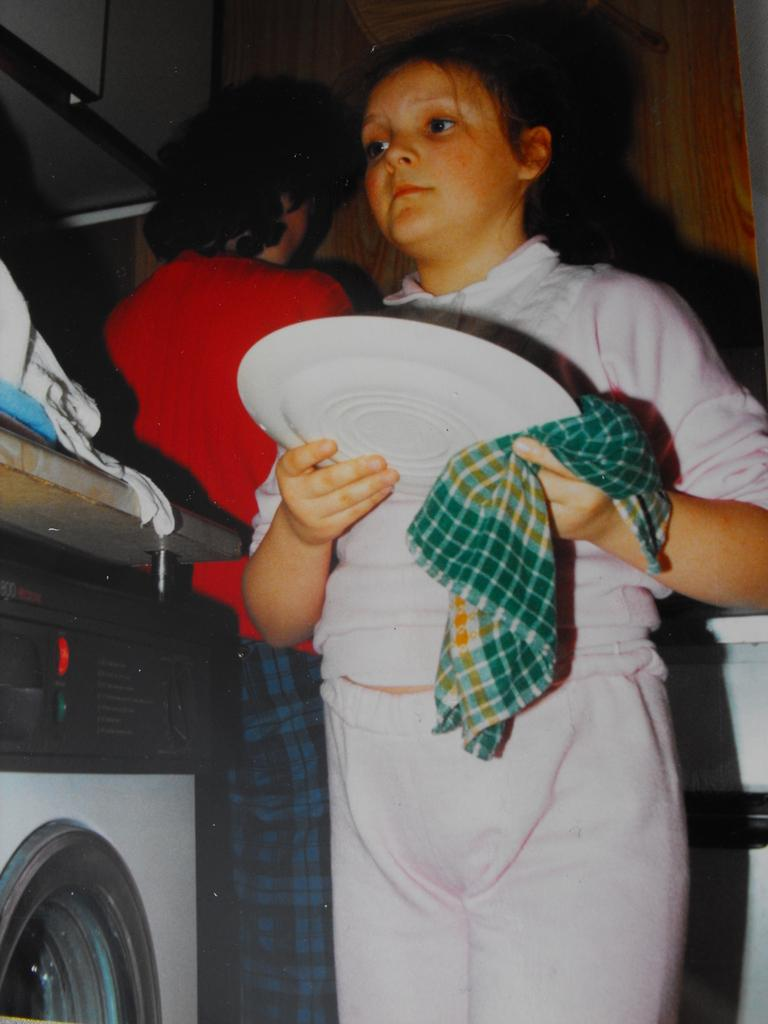How many people are in the image? There are two persons in the image. What is one person doing in the image? One person is catching a plate and a cloth with their hand. What appliance can be seen in the image? There is a washing machine in the image. What type of rail can be seen in the downtown area in the image? There is no downtown area or rail present in the image. What type of pickle is being used to clean the plate in the image? There is no pickle present in the image; the person is catching a plate and a cloth with their hand. 